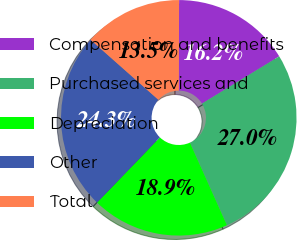Convert chart. <chart><loc_0><loc_0><loc_500><loc_500><pie_chart><fcel>Compensation and benefits<fcel>Purchased services and<fcel>Depreciation<fcel>Other<fcel>Total<nl><fcel>16.22%<fcel>27.03%<fcel>18.92%<fcel>24.32%<fcel>13.51%<nl></chart> 